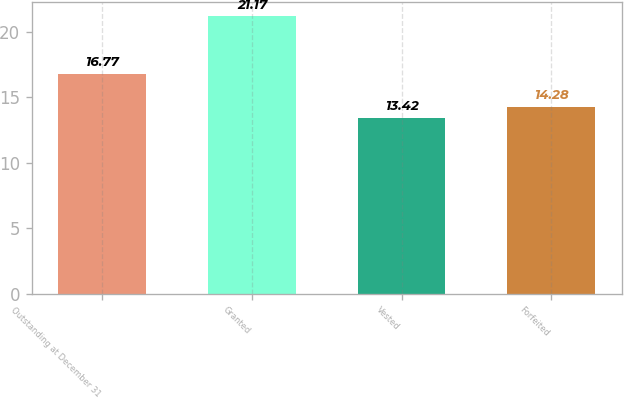Convert chart to OTSL. <chart><loc_0><loc_0><loc_500><loc_500><bar_chart><fcel>Outstanding at December 31<fcel>Granted<fcel>Vested<fcel>Forfeited<nl><fcel>16.77<fcel>21.17<fcel>13.42<fcel>14.28<nl></chart> 